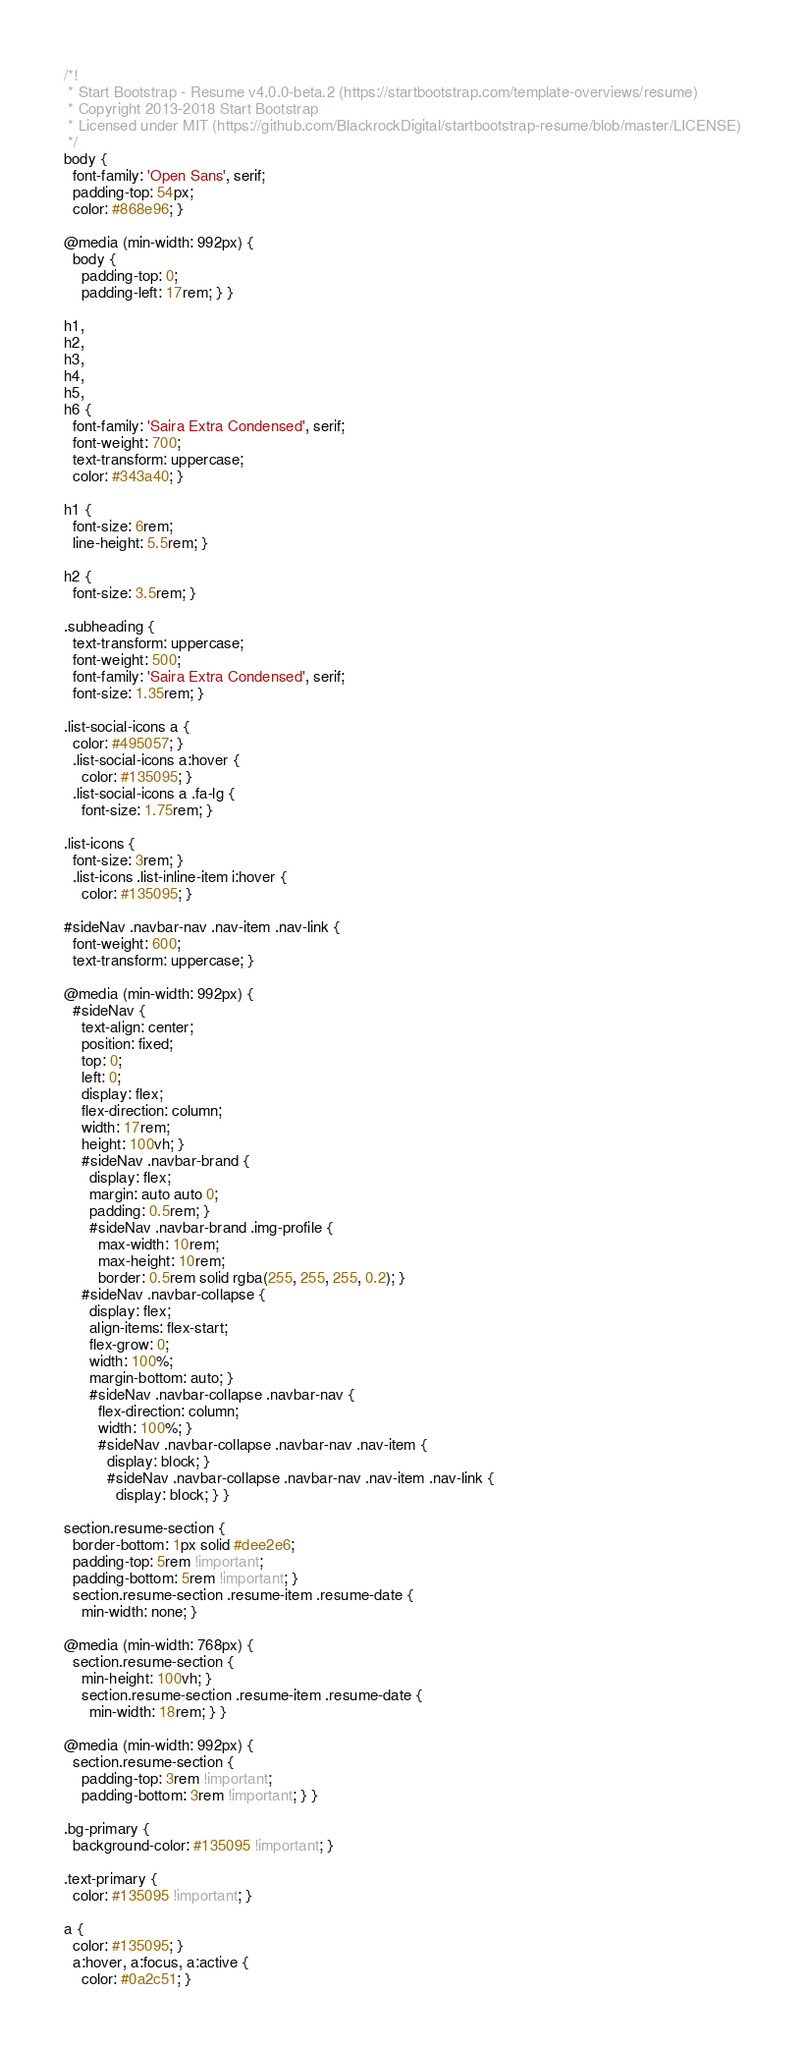<code> <loc_0><loc_0><loc_500><loc_500><_CSS_>/*!
 * Start Bootstrap - Resume v4.0.0-beta.2 (https://startbootstrap.com/template-overviews/resume)
 * Copyright 2013-2018 Start Bootstrap
 * Licensed under MIT (https://github.com/BlackrockDigital/startbootstrap-resume/blob/master/LICENSE)
 */
body {
  font-family: 'Open Sans', serif;
  padding-top: 54px;
  color: #868e96; }

@media (min-width: 992px) {
  body {
    padding-top: 0;
    padding-left: 17rem; } }

h1,
h2,
h3,
h4,
h5,
h6 {
  font-family: 'Saira Extra Condensed', serif;
  font-weight: 700;
  text-transform: uppercase;
  color: #343a40; }

h1 {
  font-size: 6rem;
  line-height: 5.5rem; }

h2 {
  font-size: 3.5rem; }

.subheading {
  text-transform: uppercase;
  font-weight: 500;
  font-family: 'Saira Extra Condensed', serif;
  font-size: 1.35rem; }

.list-social-icons a {
  color: #495057; }
  .list-social-icons a:hover {
    color: #135095; }
  .list-social-icons a .fa-lg {
    font-size: 1.75rem; }

.list-icons {
  font-size: 3rem; }
  .list-icons .list-inline-item i:hover {
    color: #135095; }

#sideNav .navbar-nav .nav-item .nav-link {
  font-weight: 600;
  text-transform: uppercase; }

@media (min-width: 992px) {
  #sideNav {
    text-align: center;
    position: fixed;
    top: 0;
    left: 0;
    display: flex;
    flex-direction: column;
    width: 17rem;
    height: 100vh; }
    #sideNav .navbar-brand {
      display: flex;
      margin: auto auto 0;
      padding: 0.5rem; }
      #sideNav .navbar-brand .img-profile {
        max-width: 10rem;
        max-height: 10rem;
        border: 0.5rem solid rgba(255, 255, 255, 0.2); }
    #sideNav .navbar-collapse {
      display: flex;
      align-items: flex-start;
      flex-grow: 0;
      width: 100%;
      margin-bottom: auto; }
      #sideNav .navbar-collapse .navbar-nav {
        flex-direction: column;
        width: 100%; }
        #sideNav .navbar-collapse .navbar-nav .nav-item {
          display: block; }
          #sideNav .navbar-collapse .navbar-nav .nav-item .nav-link {
            display: block; } }

section.resume-section {
  border-bottom: 1px solid #dee2e6;
  padding-top: 5rem !important;
  padding-bottom: 5rem !important; }
  section.resume-section .resume-item .resume-date {
    min-width: none; }

@media (min-width: 768px) {
  section.resume-section {
    min-height: 100vh; }
    section.resume-section .resume-item .resume-date {
      min-width: 18rem; } }

@media (min-width: 992px) {
  section.resume-section {
    padding-top: 3rem !important;
    padding-bottom: 3rem !important; } }

.bg-primary {
  background-color: #135095 !important; }

.text-primary {
  color: #135095 !important; }

a {
  color: #135095; }
  a:hover, a:focus, a:active {
    color: #0a2c51; }
</code> 